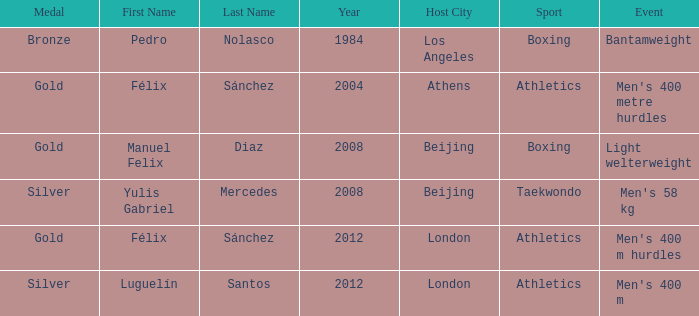Which games possessed a moniker of manuel felix diaz? 2008 Beijing. 